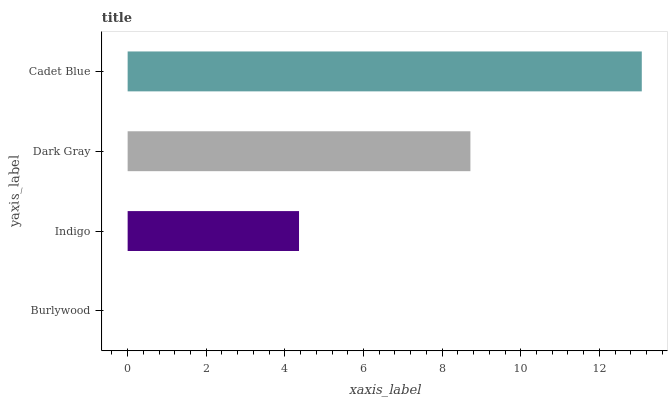Is Burlywood the minimum?
Answer yes or no. Yes. Is Cadet Blue the maximum?
Answer yes or no. Yes. Is Indigo the minimum?
Answer yes or no. No. Is Indigo the maximum?
Answer yes or no. No. Is Indigo greater than Burlywood?
Answer yes or no. Yes. Is Burlywood less than Indigo?
Answer yes or no. Yes. Is Burlywood greater than Indigo?
Answer yes or no. No. Is Indigo less than Burlywood?
Answer yes or no. No. Is Dark Gray the high median?
Answer yes or no. Yes. Is Indigo the low median?
Answer yes or no. Yes. Is Burlywood the high median?
Answer yes or no. No. Is Burlywood the low median?
Answer yes or no. No. 